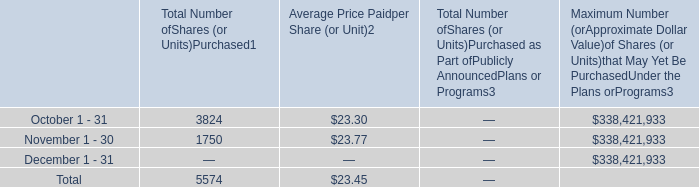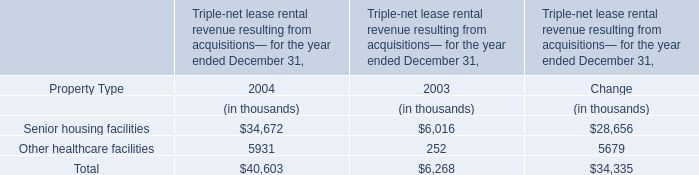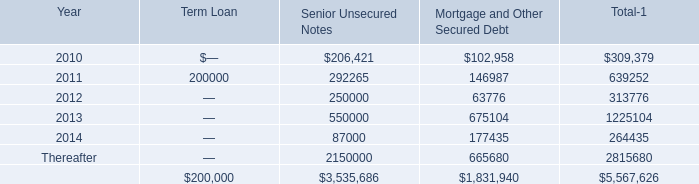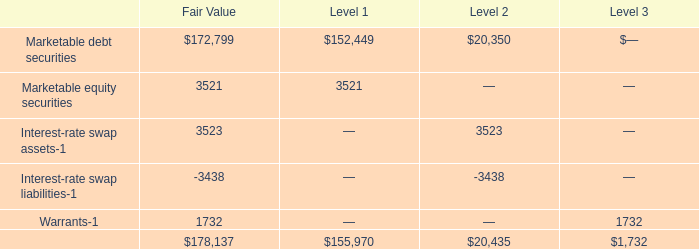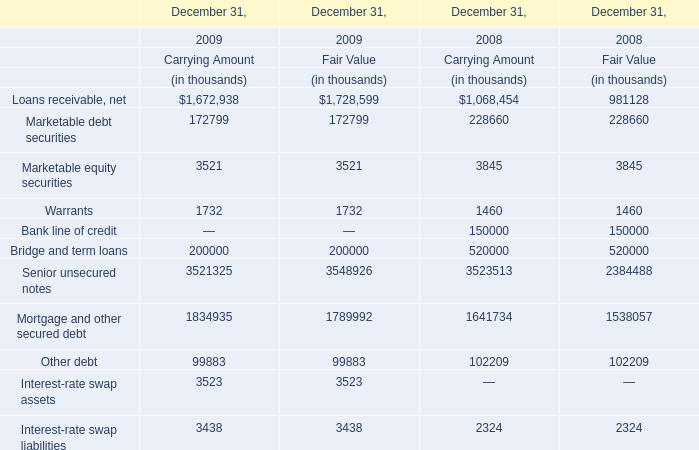what was the potential cash payment for the cash dividend announced that our board of directors in 2019 
Computations: (10000 * 0.235)
Answer: 2350.0. 